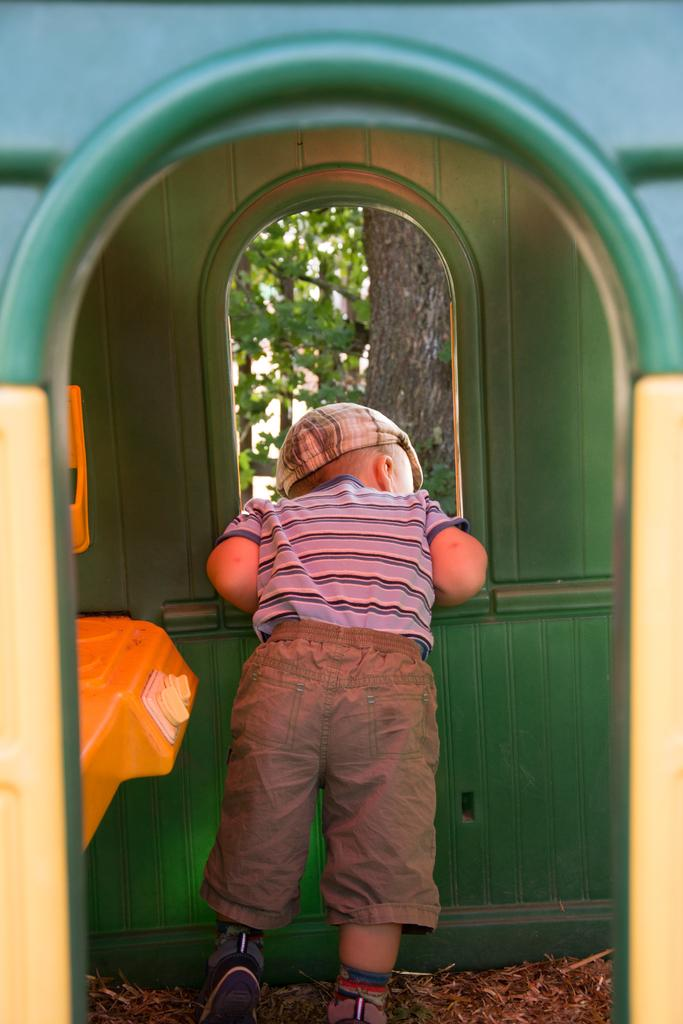Who is present in the room in the image? There is a small boy in the room. What can be seen in the room? There is a window in the room. What is visible through the window? Trees are visible through the window. What type of jam is being discussed by the small boy in the image? There is no indication in the image that the small boy is discussing jam or any other food item. 